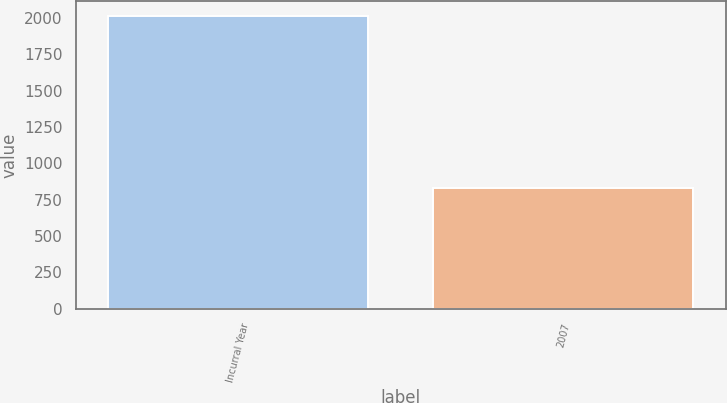Convert chart to OTSL. <chart><loc_0><loc_0><loc_500><loc_500><bar_chart><fcel>Incurral Year<fcel>2007<nl><fcel>2014<fcel>828<nl></chart> 